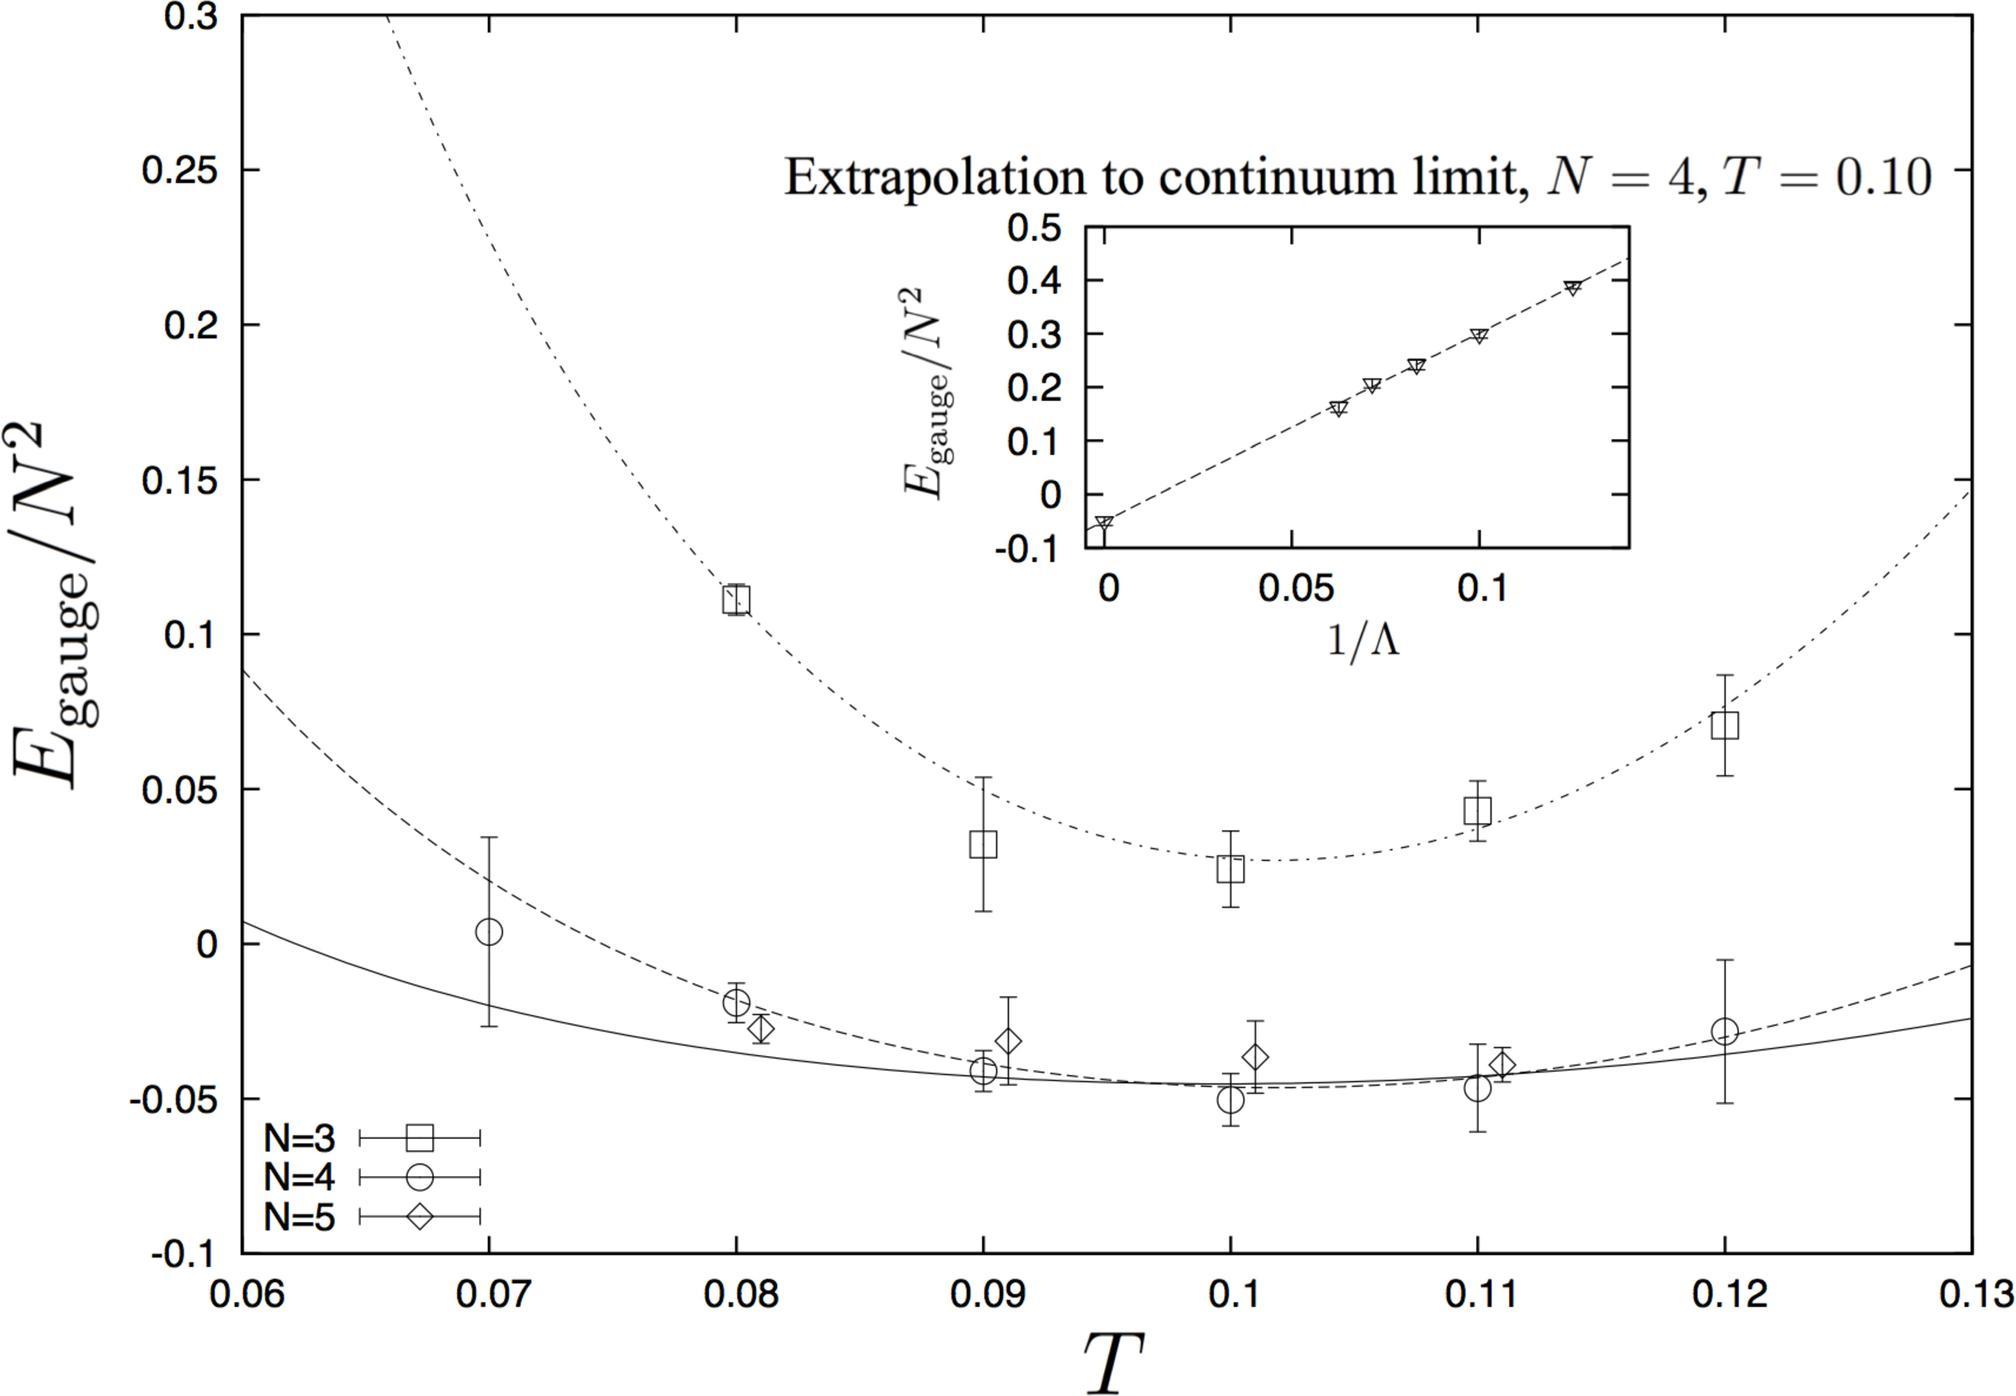What does the inset graph in the figure represent? The inset graph, prominently labeled 'Extrapolation to continuum limit, N = 4, T = 0.10,' is crucial for illustrating the continuation and extrapolation of gauge energy values to a zero lattice spacing, achieving true continuum conditions. This graphical representation aids in exploring the theoretical predictions of gauge energies at the specified parameters N and T, offering an insight into how these values converge at finer resolutions. 